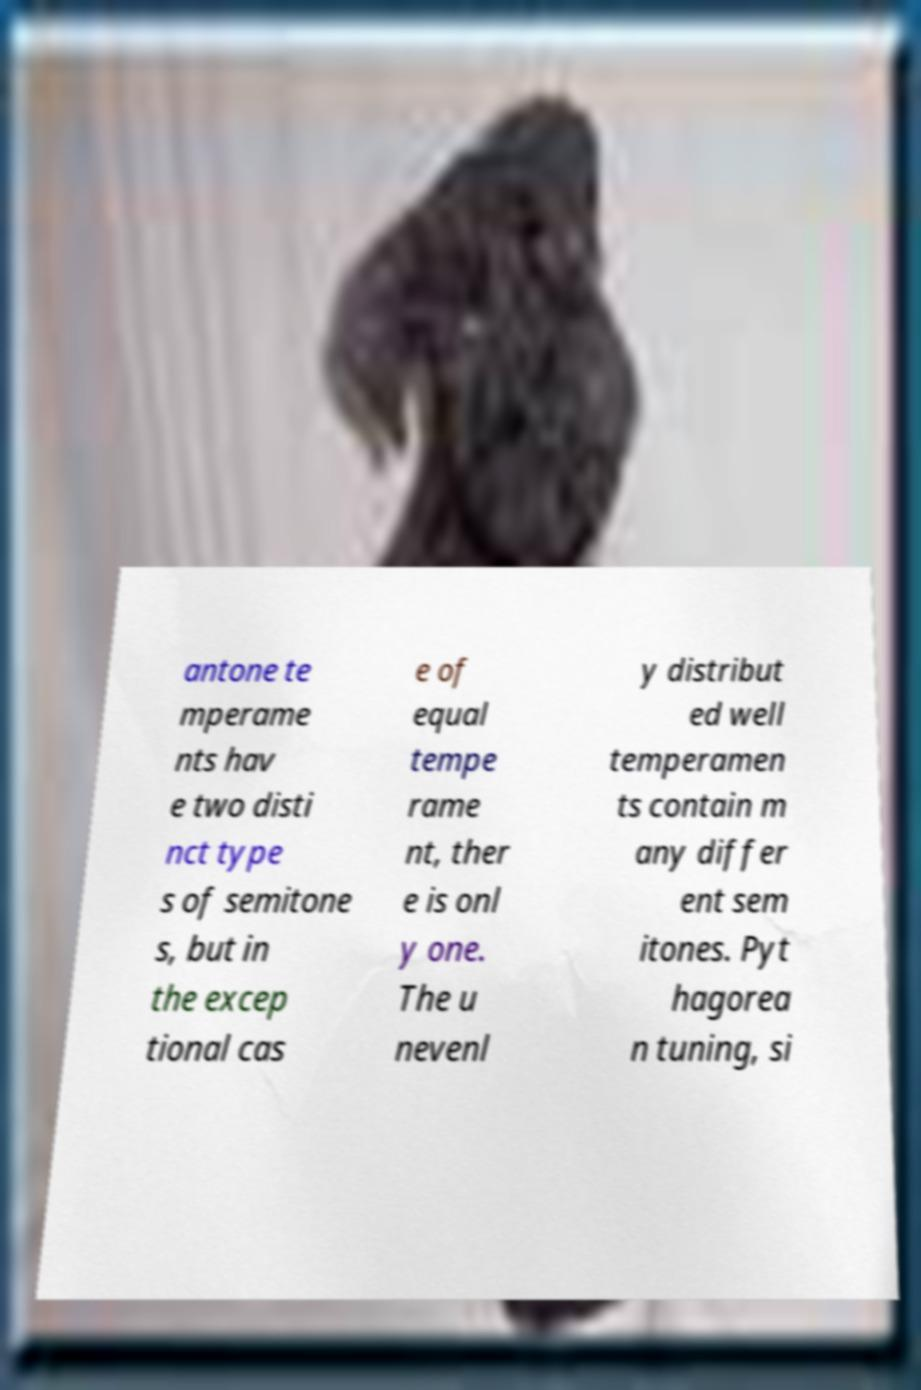Can you read and provide the text displayed in the image?This photo seems to have some interesting text. Can you extract and type it out for me? antone te mperame nts hav e two disti nct type s of semitone s, but in the excep tional cas e of equal tempe rame nt, ther e is onl y one. The u nevenl y distribut ed well temperamen ts contain m any differ ent sem itones. Pyt hagorea n tuning, si 